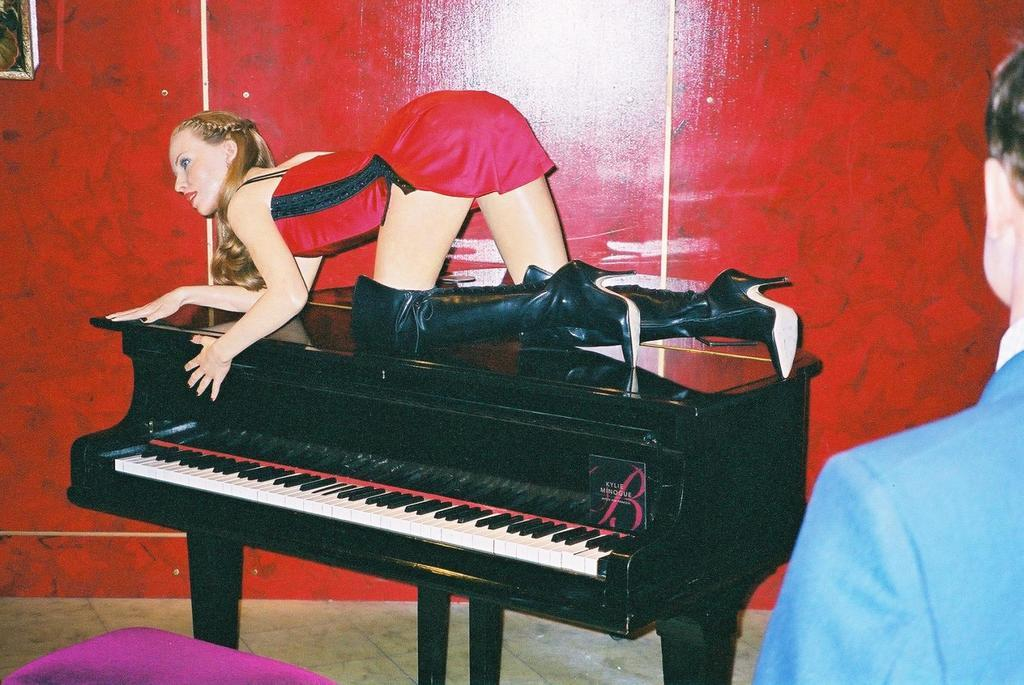What is the person doing in the image? The person is above the piano. What can be seen behind the person? There is a wall visible in the background. What surface is the person standing on? The floor is present in the image. How many chairs are present in the image? There is no mention of chairs in the image, so it is impossible to determine their number. 